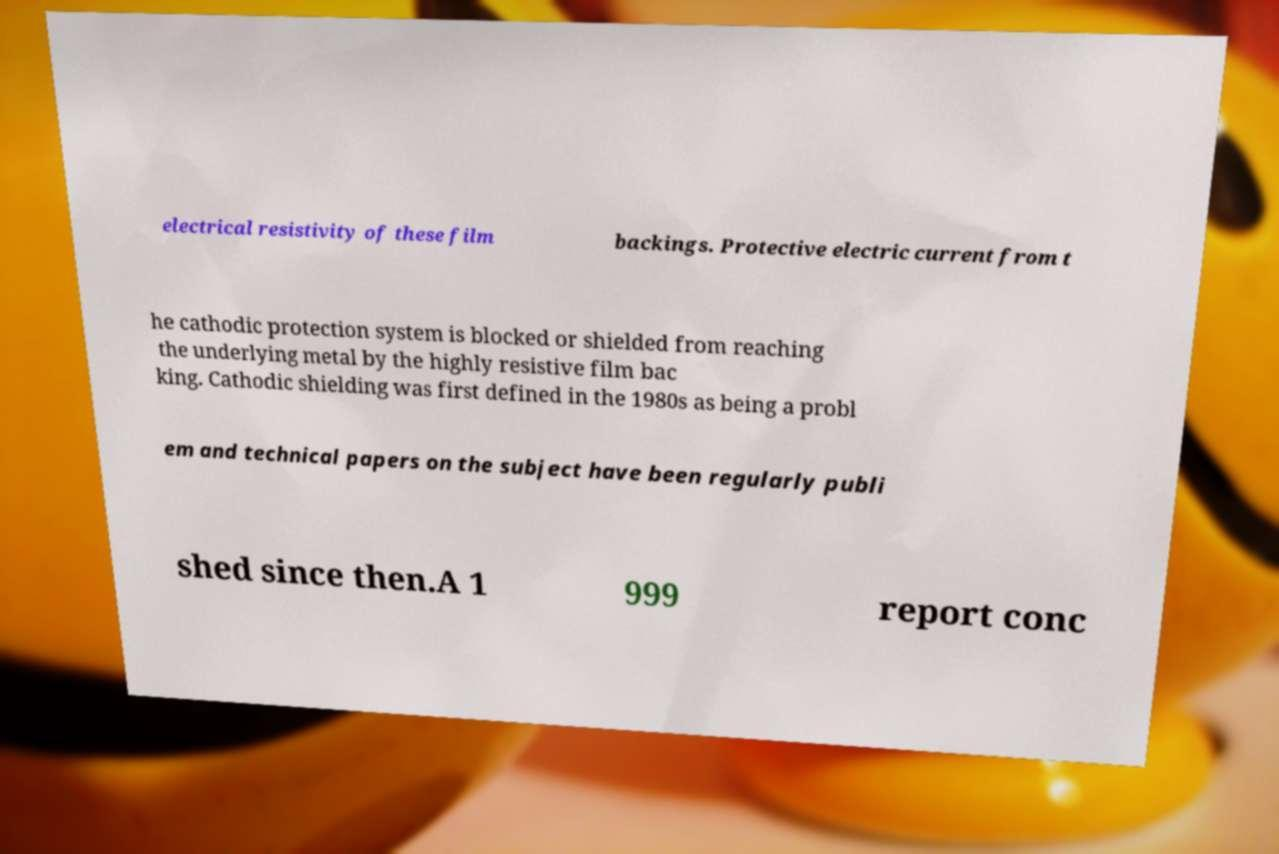Can you read and provide the text displayed in the image?This photo seems to have some interesting text. Can you extract and type it out for me? electrical resistivity of these film backings. Protective electric current from t he cathodic protection system is blocked or shielded from reaching the underlying metal by the highly resistive film bac king. Cathodic shielding was first defined in the 1980s as being a probl em and technical papers on the subject have been regularly publi shed since then.A 1 999 report conc 